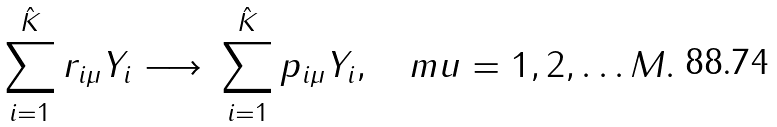Convert formula to latex. <formula><loc_0><loc_0><loc_500><loc_500>\sum _ { i = 1 } ^ { \hat { K } } r _ { i \mu } Y _ { i } \ { \longrightarrow } \ \sum _ { i = 1 } ^ { \hat { K } } p _ { i \mu } Y _ { i } , \quad m u = 1 , 2 , \dots M .</formula> 